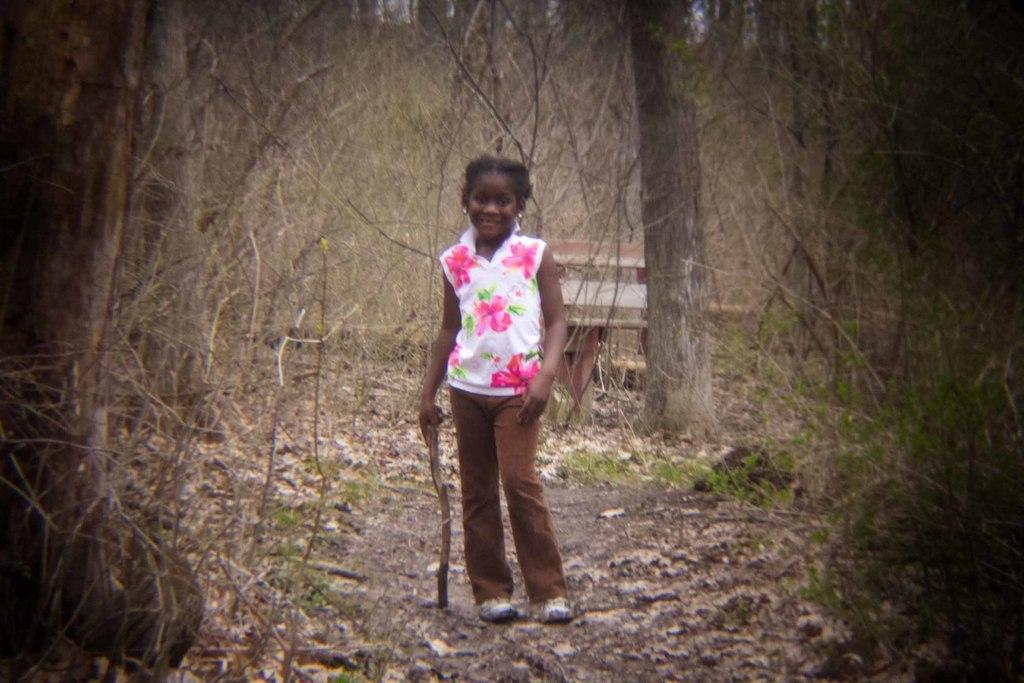In one or two sentences, can you explain what this image depicts? This image consists of a girl holding a stick. At the bottom, there are dried leaves on the ground. In the background, we can see many trees. 